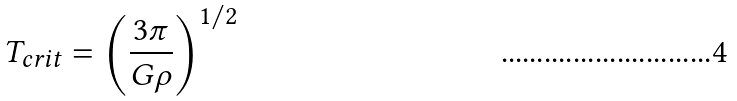<formula> <loc_0><loc_0><loc_500><loc_500>T _ { c r i t } = \left ( \frac { 3 \pi } { G \rho } \right ) ^ { 1 / 2 }</formula> 